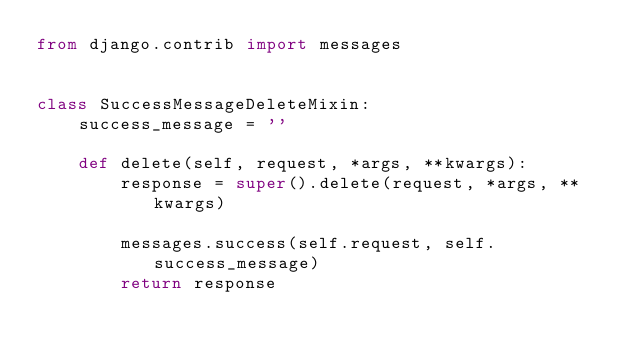Convert code to text. <code><loc_0><loc_0><loc_500><loc_500><_Python_>from django.contrib import messages


class SuccessMessageDeleteMixin:
    success_message = ''

    def delete(self, request, *args, **kwargs):
        response = super().delete(request, *args, **kwargs)

        messages.success(self.request, self.success_message)
        return response
</code> 